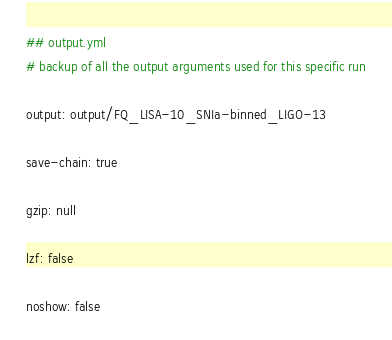Convert code to text. <code><loc_0><loc_0><loc_500><loc_500><_YAML_>## output.yml
# backup of all the output arguments used for this specific run

output: output/FQ_LISA-10_SNIa-binned_LIGO-13

save-chain: true

gzip: null

lzf: false

noshow: false

</code> 